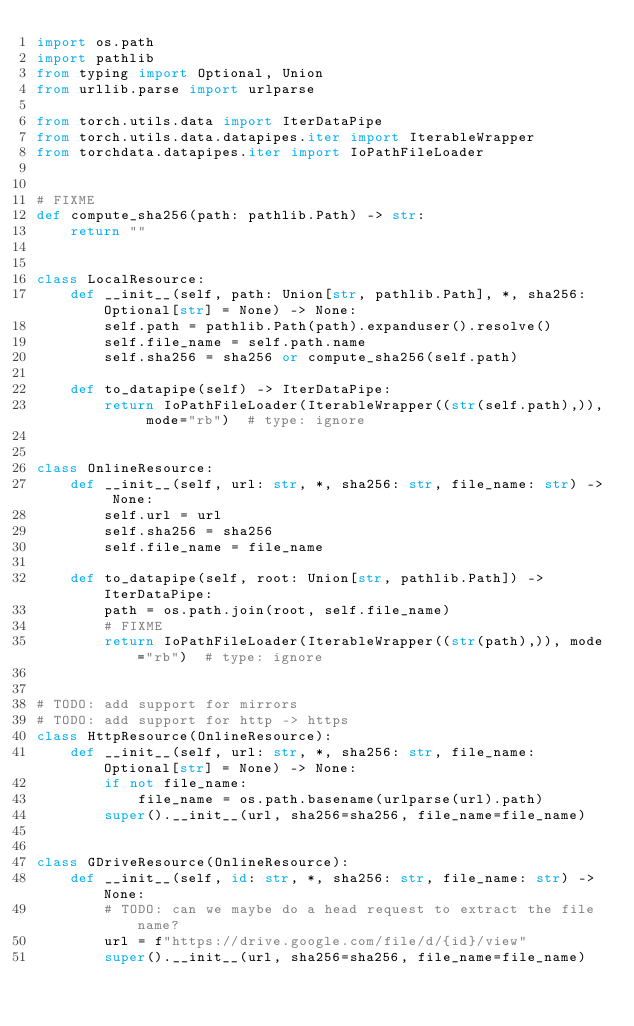Convert code to text. <code><loc_0><loc_0><loc_500><loc_500><_Python_>import os.path
import pathlib
from typing import Optional, Union
from urllib.parse import urlparse

from torch.utils.data import IterDataPipe
from torch.utils.data.datapipes.iter import IterableWrapper
from torchdata.datapipes.iter import IoPathFileLoader


# FIXME
def compute_sha256(path: pathlib.Path) -> str:
    return ""


class LocalResource:
    def __init__(self, path: Union[str, pathlib.Path], *, sha256: Optional[str] = None) -> None:
        self.path = pathlib.Path(path).expanduser().resolve()
        self.file_name = self.path.name
        self.sha256 = sha256 or compute_sha256(self.path)

    def to_datapipe(self) -> IterDataPipe:
        return IoPathFileLoader(IterableWrapper((str(self.path),)), mode="rb")  # type: ignore


class OnlineResource:
    def __init__(self, url: str, *, sha256: str, file_name: str) -> None:
        self.url = url
        self.sha256 = sha256
        self.file_name = file_name

    def to_datapipe(self, root: Union[str, pathlib.Path]) -> IterDataPipe:
        path = os.path.join(root, self.file_name)
        # FIXME
        return IoPathFileLoader(IterableWrapper((str(path),)), mode="rb")  # type: ignore


# TODO: add support for mirrors
# TODO: add support for http -> https
class HttpResource(OnlineResource):
    def __init__(self, url: str, *, sha256: str, file_name: Optional[str] = None) -> None:
        if not file_name:
            file_name = os.path.basename(urlparse(url).path)
        super().__init__(url, sha256=sha256, file_name=file_name)


class GDriveResource(OnlineResource):
    def __init__(self, id: str, *, sha256: str, file_name: str) -> None:
        # TODO: can we maybe do a head request to extract the file name?
        url = f"https://drive.google.com/file/d/{id}/view"
        super().__init__(url, sha256=sha256, file_name=file_name)
</code> 